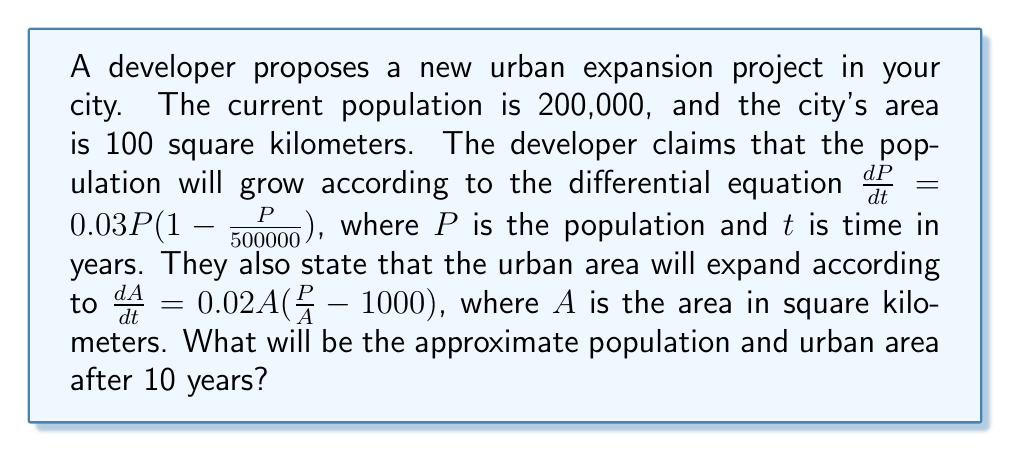Could you help me with this problem? To solve this problem, we need to use numerical methods to approximate the solutions to the given differential equations.

1. For the population growth:
   $\frac{dP}{dt} = 0.03P(1 - \frac{P}{500000})$
   
   We can use Euler's method with a step size of 1 year:
   $P_{n+1} = P_n + 0.03P_n(1 - \frac{P_n}{500000})$

   Starting with $P_0 = 200,000$, we iterate 10 times:
   
   $P_1 = 200,000 + 0.03 \cdot 200,000(1 - \frac{200,000}{500,000}) = 204,800$
   $P_2 = 209,395$
   ...
   $P_{10} \approx 244,326$

2. For the urban area expansion:
   $\frac{dA}{dt} = 0.02A(\frac{P}{A} - 1000)$
   
   We use Euler's method again, but we need to update $P$ in each step:
   $A_{n+1} = A_n + 0.02A_n(\frac{P_n}{A_n} - 1000)$

   Starting with $A_0 = 100$, we iterate 10 times:
   
   $A_1 = 100 + 0.02 \cdot 100(\frac{204,800}{100} - 1000) = 109.6$
   $A_2 = 119.0$
   ...
   $A_{10} \approx 183.2$

Therefore, after 10 years, the population will be approximately 244,326, and the urban area will be approximately 183.2 square kilometers.
Answer: Population: 244,326; Urban area: 183.2 sq km 